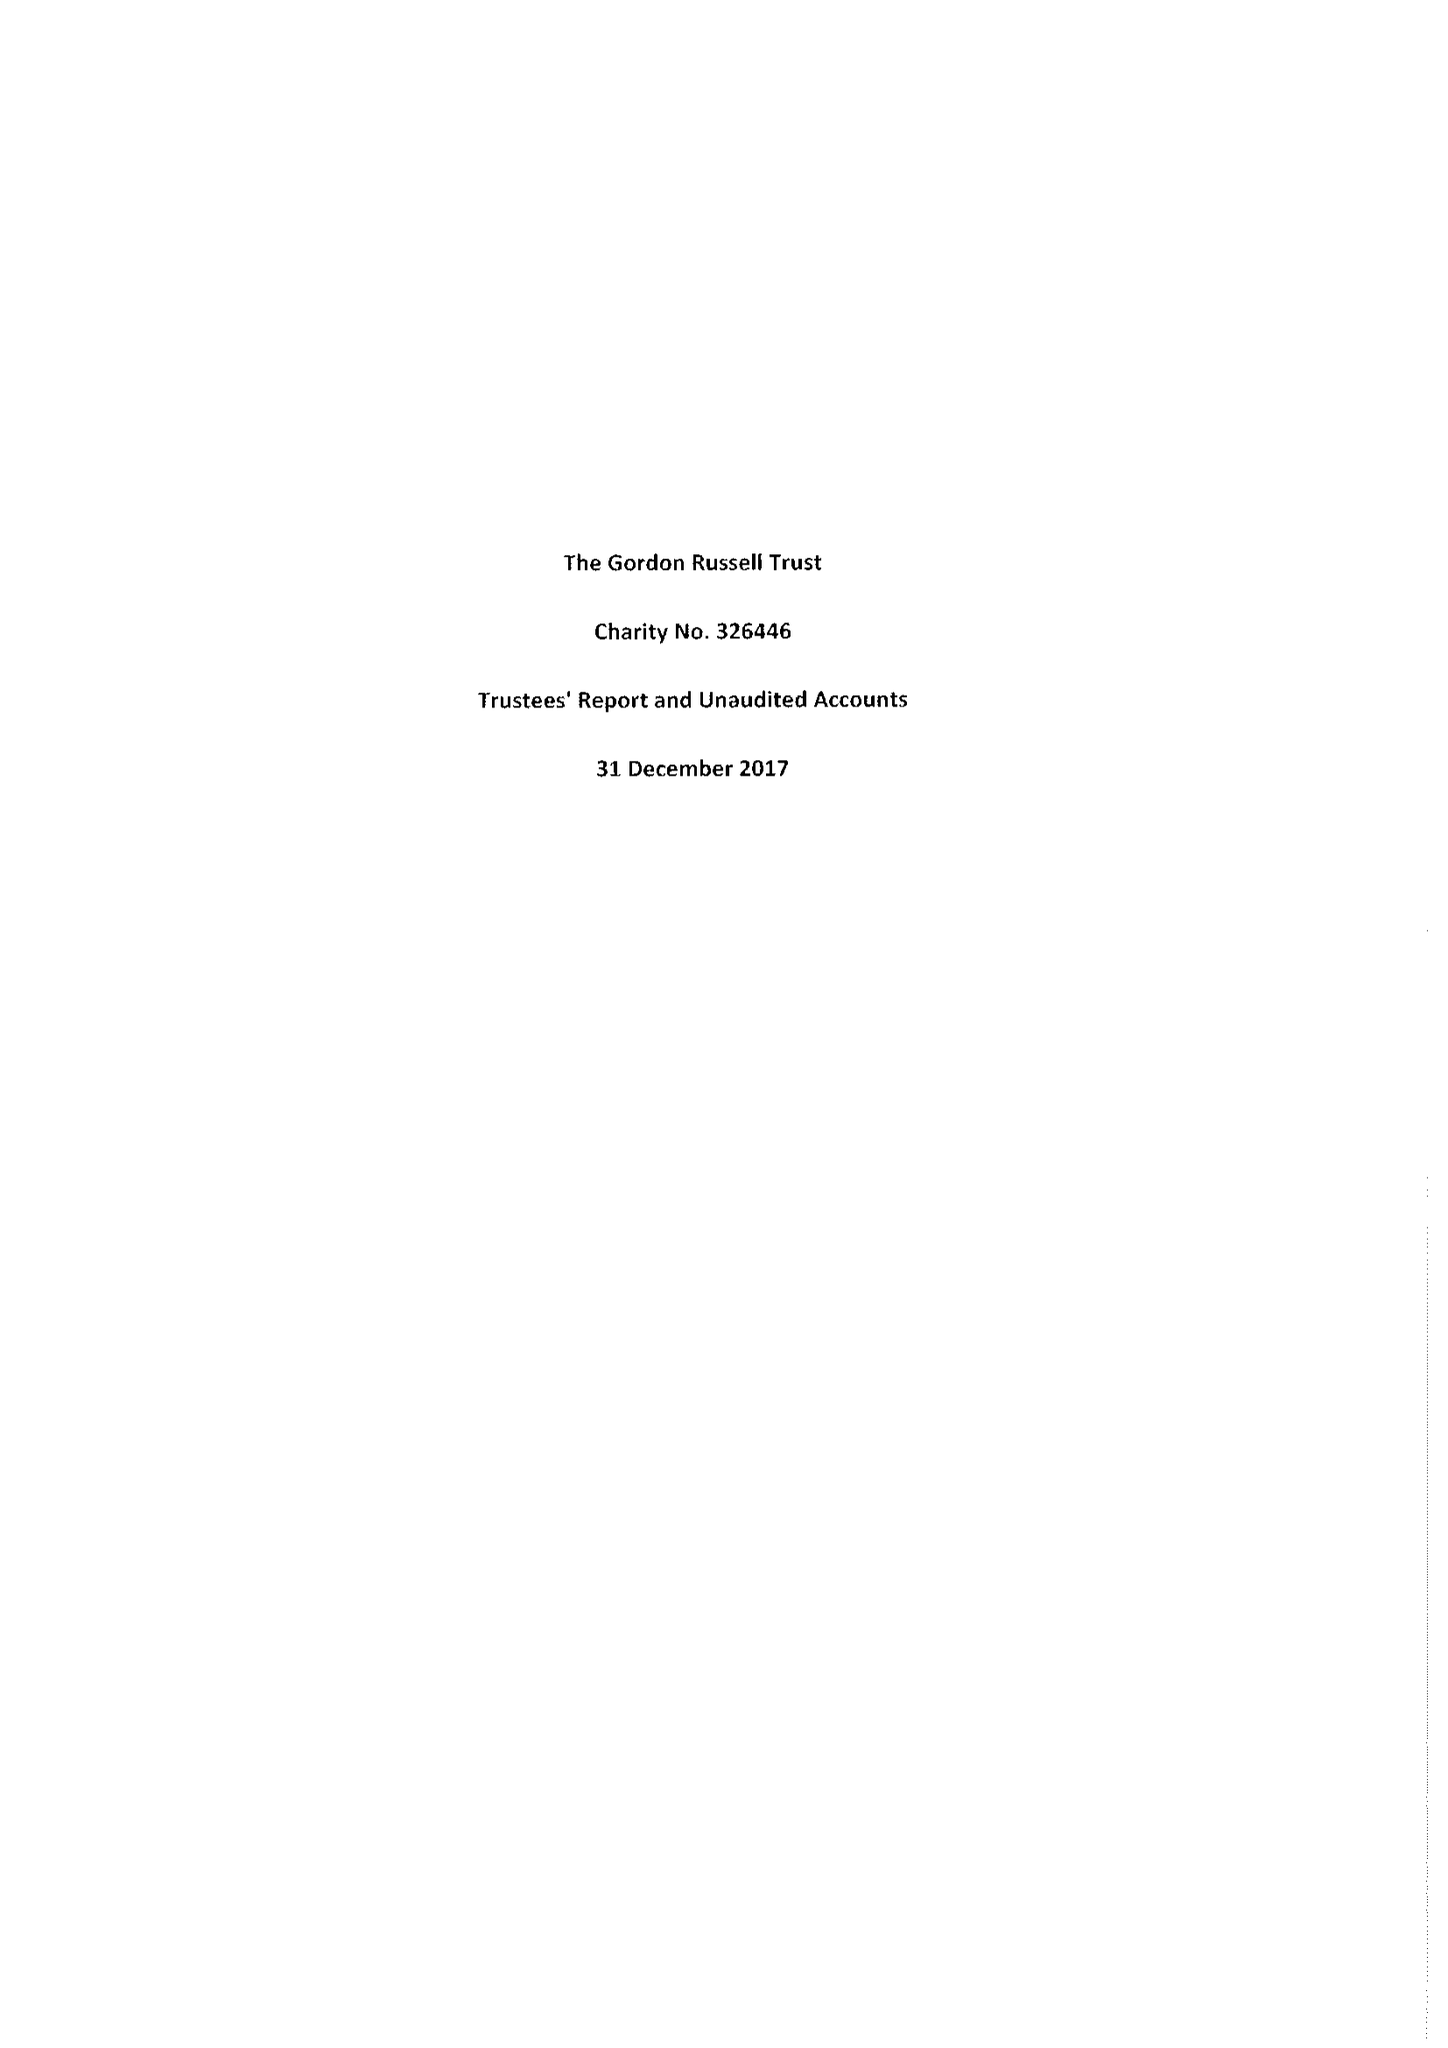What is the value for the income_annually_in_british_pounds?
Answer the question using a single word or phrase. 56793.00 